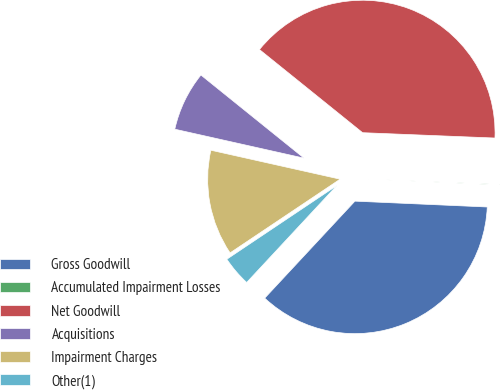Convert chart to OTSL. <chart><loc_0><loc_0><loc_500><loc_500><pie_chart><fcel>Gross Goodwill<fcel>Accumulated Impairment Losses<fcel>Net Goodwill<fcel>Acquisitions<fcel>Impairment Charges<fcel>Other(1)<nl><fcel>36.22%<fcel>0.06%<fcel>39.84%<fcel>7.29%<fcel>12.9%<fcel>3.68%<nl></chart> 